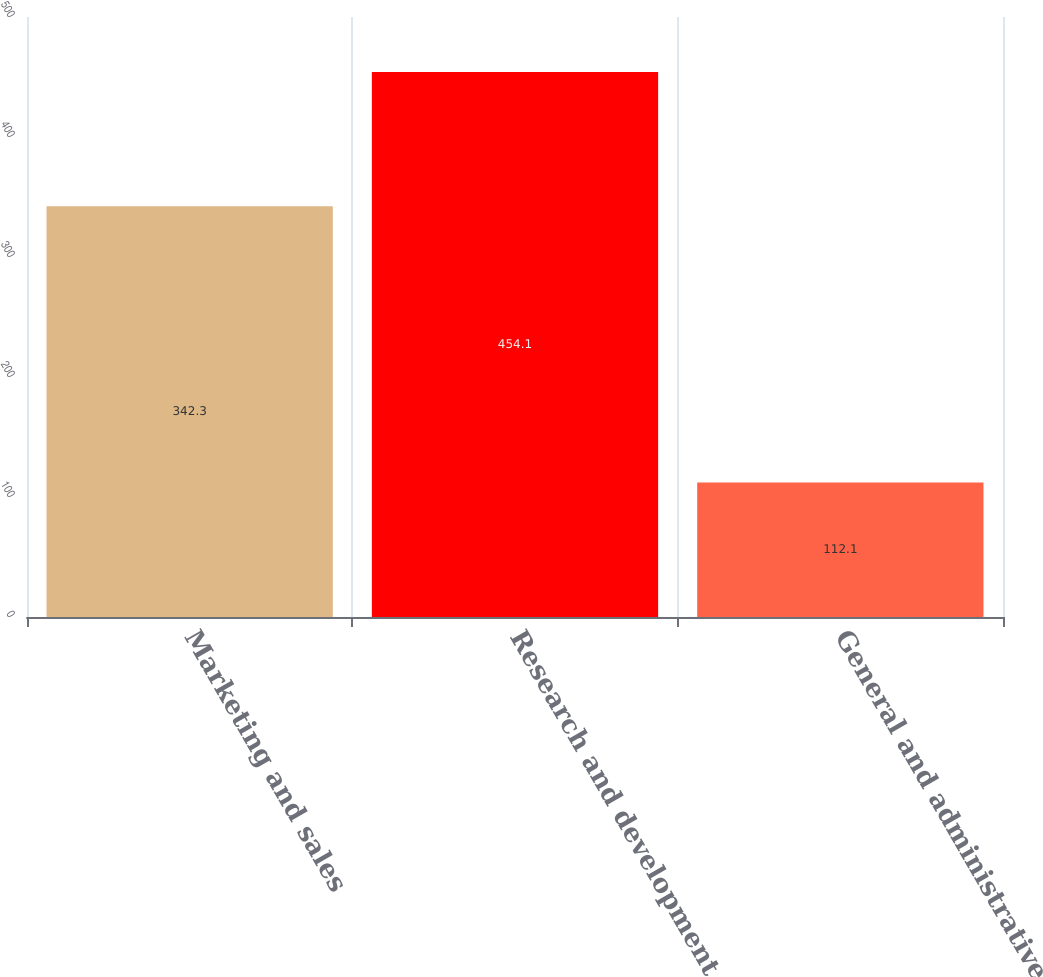Convert chart. <chart><loc_0><loc_0><loc_500><loc_500><bar_chart><fcel>Marketing and sales<fcel>Research and development<fcel>General and administrative<nl><fcel>342.3<fcel>454.1<fcel>112.1<nl></chart> 